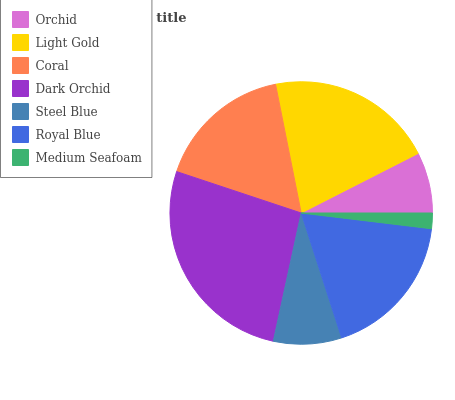Is Medium Seafoam the minimum?
Answer yes or no. Yes. Is Dark Orchid the maximum?
Answer yes or no. Yes. Is Light Gold the minimum?
Answer yes or no. No. Is Light Gold the maximum?
Answer yes or no. No. Is Light Gold greater than Orchid?
Answer yes or no. Yes. Is Orchid less than Light Gold?
Answer yes or no. Yes. Is Orchid greater than Light Gold?
Answer yes or no. No. Is Light Gold less than Orchid?
Answer yes or no. No. Is Coral the high median?
Answer yes or no. Yes. Is Coral the low median?
Answer yes or no. Yes. Is Medium Seafoam the high median?
Answer yes or no. No. Is Light Gold the low median?
Answer yes or no. No. 